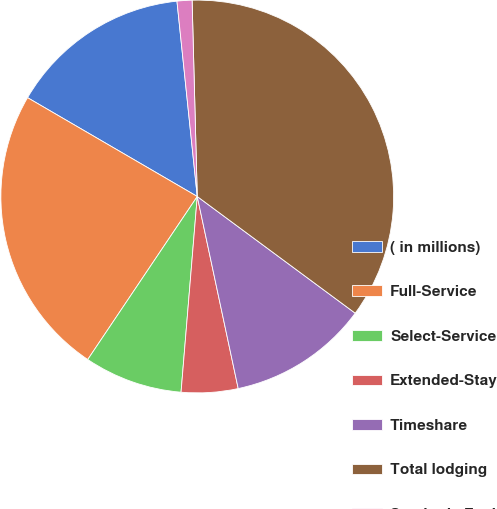Convert chart to OTSL. <chart><loc_0><loc_0><loc_500><loc_500><pie_chart><fcel>( in millions)<fcel>Full-Service<fcel>Select-Service<fcel>Extended-Stay<fcel>Timeshare<fcel>Total lodging<fcel>Synthetic Fuel<nl><fcel>14.96%<fcel>23.98%<fcel>8.1%<fcel>4.66%<fcel>11.53%<fcel>35.55%<fcel>1.23%<nl></chart> 